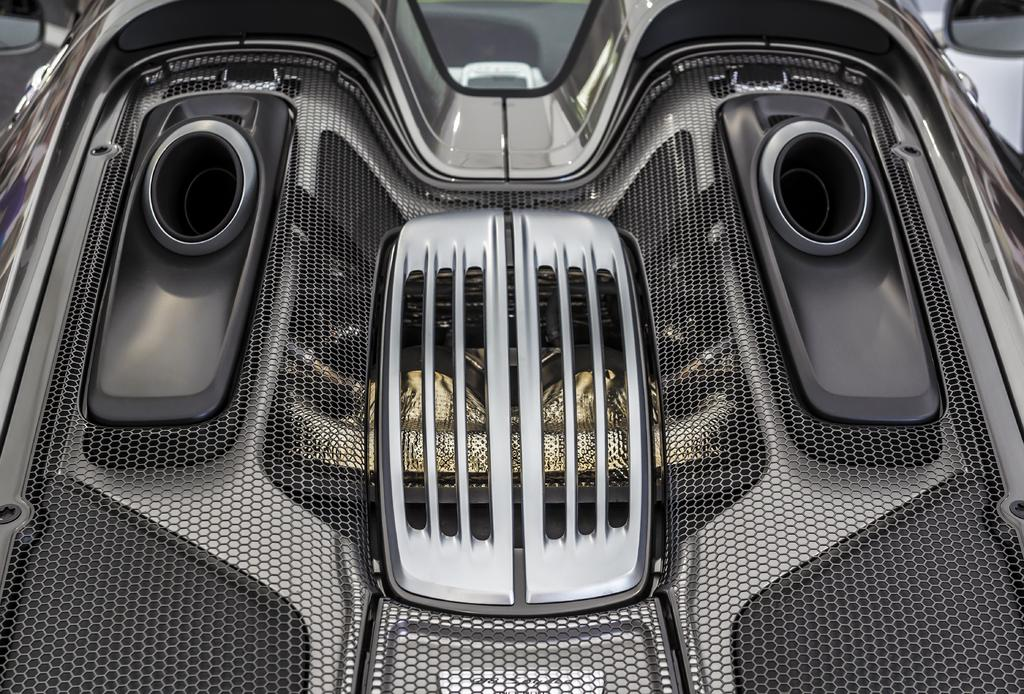What is the main subject of the image? There is an object in the image. Can you describe the color of the object? The object is black and grey in color. What type of object does it resemble? The object looks like a vehicle. What type of thing is the farmer pushing in the image? There is no farmer or any pushing activity present in the image. The image only features an object that resembles a vehicle. 